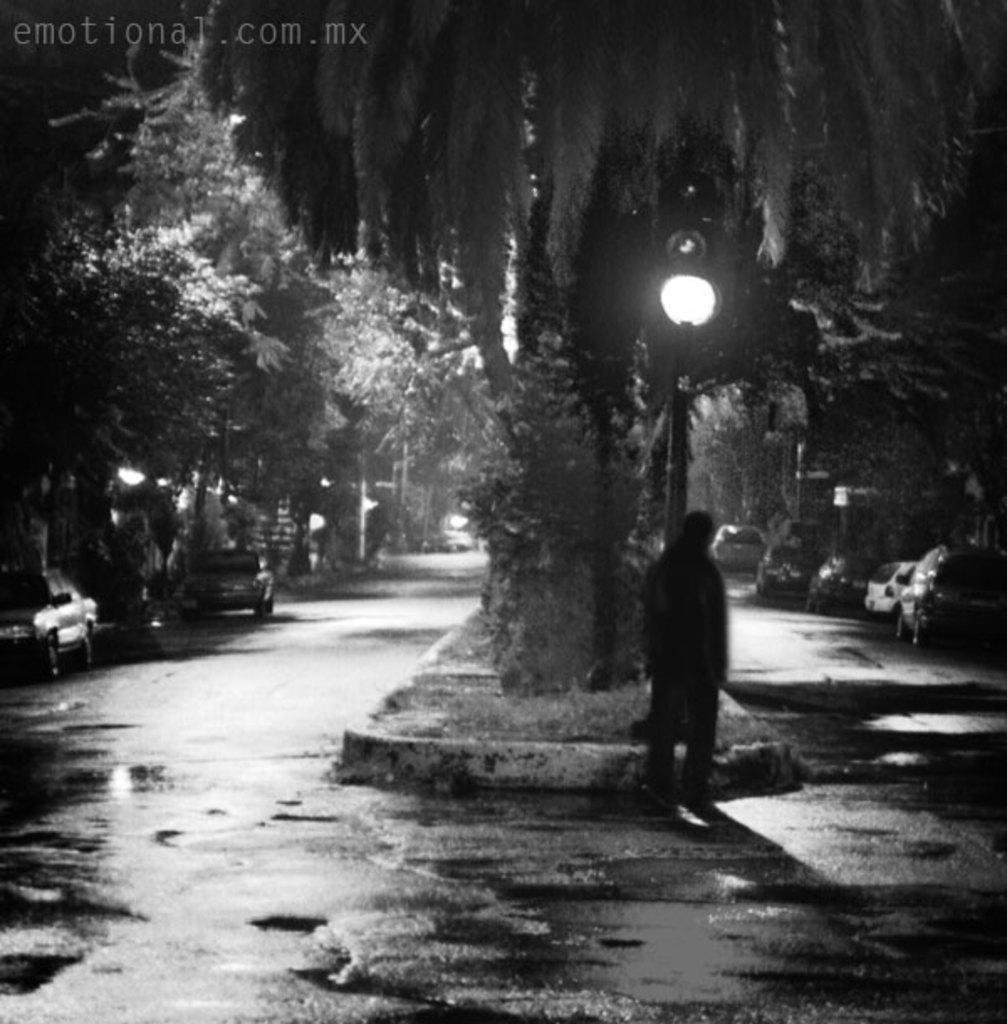Please provide a concise description of this image. This is the picture of a place where we have some cars, trees, pole which has a light and a person. 